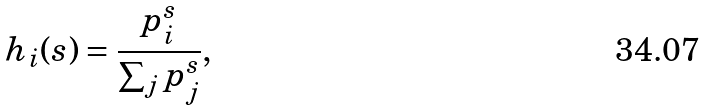Convert formula to latex. <formula><loc_0><loc_0><loc_500><loc_500>h _ { i } ( s ) = \frac { p _ { i } ^ { s } } { \sum _ { j } p _ { j } ^ { s } } ,</formula> 